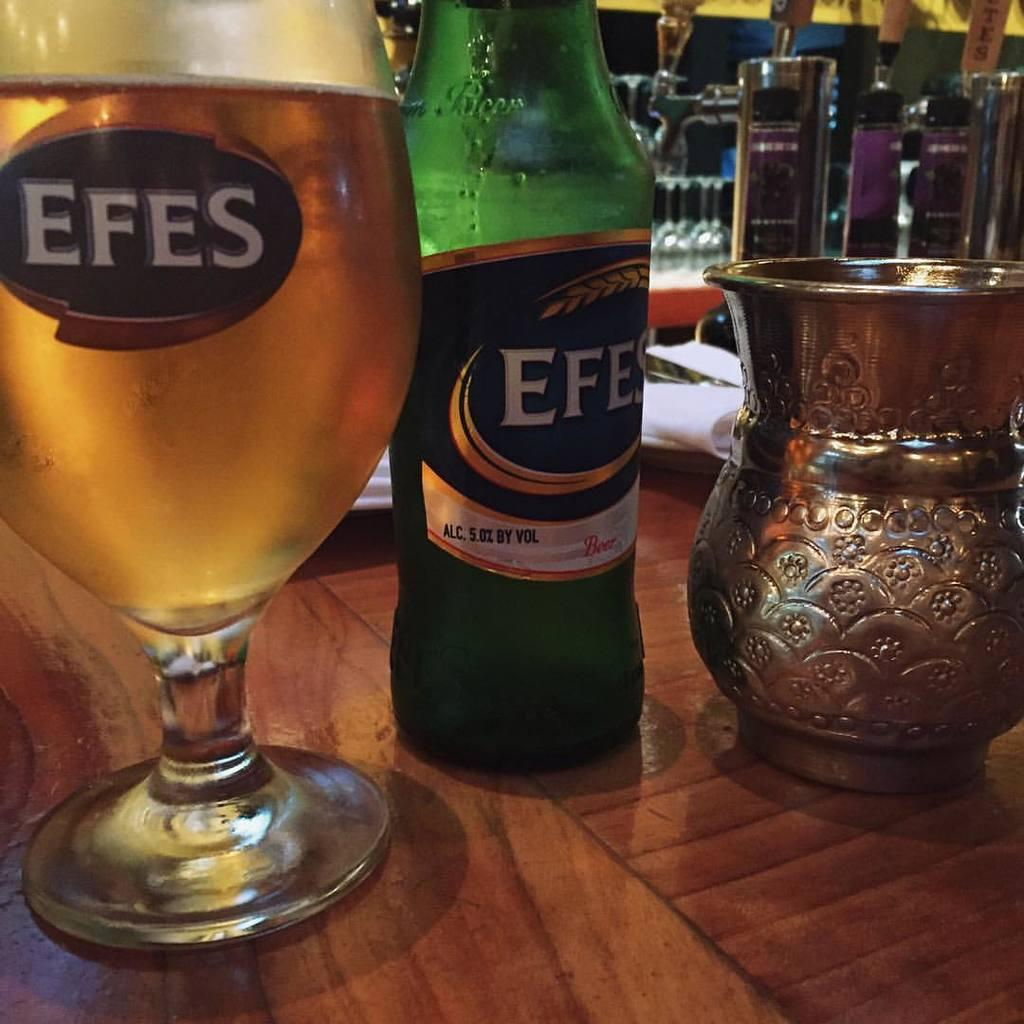What type of container is visible in the image? There is a bottle in the image. What other type of container can be seen in the image? There is a glass in the image. Are there any additional containers in the image? Yes, there is a jug in the image. What color is the kitty sitting on the zinc table in the image? There is no kitty or zinc table present in the image. How many copies of the bottle are there in the image? There is only one bottle present in the image, so there are no copies. 